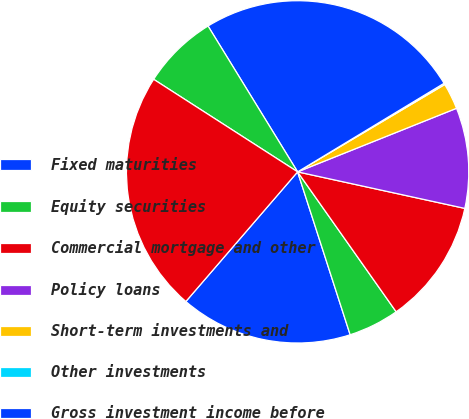Convert chart to OTSL. <chart><loc_0><loc_0><loc_500><loc_500><pie_chart><fcel>Fixed maturities<fcel>Equity securities<fcel>Commercial mortgage and other<fcel>Policy loans<fcel>Short-term investments and<fcel>Other investments<fcel>Gross investment income before<fcel>Investment expenses<fcel>Investment income after<nl><fcel>16.29%<fcel>4.8%<fcel>11.81%<fcel>9.48%<fcel>2.47%<fcel>0.13%<fcel>25.11%<fcel>7.14%<fcel>22.77%<nl></chart> 